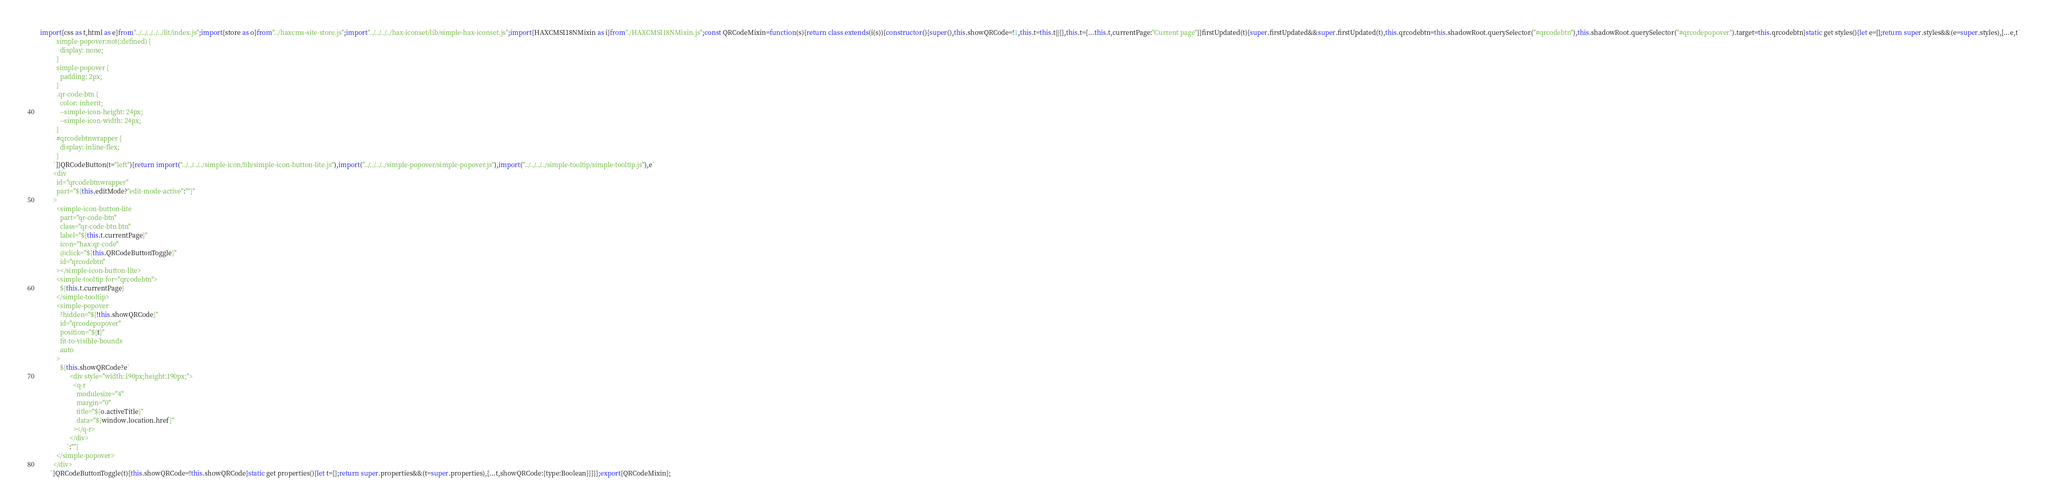Convert code to text. <code><loc_0><loc_0><loc_500><loc_500><_JavaScript_>import{css as t,html as e}from"../../../../../lit/index.js";import{store as o}from"../haxcms-site-store.js";import"../../../../hax-iconset/lib/simple-hax-iconset.js";import{HAXCMSI18NMixin as i}from"./HAXCMSI18NMixin.js";const QRCodeMixin=function(s){return class extends(i(s)){constructor(){super(),this.showQRCode=!1,this.t=this.t||{},this.t={...this.t,currentPage:"Current page"}}firstUpdated(t){super.firstUpdated&&super.firstUpdated(t),this.qrcodebtn=this.shadowRoot.querySelector("#qrcodebtn"),this.shadowRoot.querySelector("#qrcodepopover").target=this.qrcodebtn}static get styles(){let e=[];return super.styles&&(e=super.styles),[...e,t`
          simple-popover:not(:defined) {
            display: none;
          }
          simple-popover {
            padding: 2px;
          }
          .qr-code-btn {
            color: inherit;
            --simple-icon-height: 24px;
            --simple-icon-width: 24px;
          }
          #qrcodebtnwrapper {
            display: inline-flex;
          }
        `]}QRCodeButton(t="left"){return import("../../../../simple-icon/lib/simple-icon-button-lite.js"),import("../../../../simple-popover/simple-popover.js"),import("../../../../simple-tooltip/simple-tooltip.js"),e`
        <div
          id="qrcodebtnwrapper"
          part="${this.editMode?"edit-mode-active":""}"
        >
          <simple-icon-button-lite
            part="qr-code-btn"
            class="qr-code-btn btn"
            label="${this.t.currentPage}"
            icon="hax:qr-code"
            @click="${this.QRCodeButtonToggle}"
            id="qrcodebtn"
          ></simple-icon-button-lite>
          <simple-tooltip for="qrcodebtn">
            ${this.t.currentPage}
          </simple-tooltip>
          <simple-popover
            ?hidden="${!this.showQRCode}"
            id="qrcodepopover"
            position="${t}"
            fit-to-visible-bounds
            auto
          >
            ${this.showQRCode?e`
                  <div style="width:190px;height:190px;">
                    <q-r
                      modulesize="4"
                      margin="0"
                      title="${o.activeTitle}"
                      data="${window.location.href}"
                    ></q-r>
                  </div>
                `:""}
          </simple-popover>
        </div>
      `}QRCodeButtonToggle(t){this.showQRCode=!this.showQRCode}static get properties(){let t={};return super.properties&&(t=super.properties),{...t,showQRCode:{type:Boolean}}}}};export{QRCodeMixin};</code> 